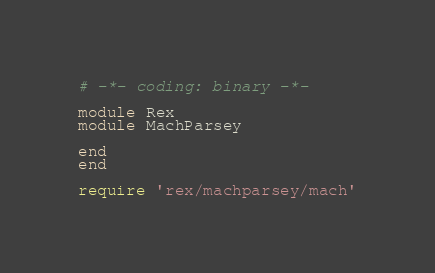<code> <loc_0><loc_0><loc_500><loc_500><_Ruby_># -*- coding: binary -*-

module Rex
module MachParsey

end
end

require 'rex/machparsey/mach'
</code> 